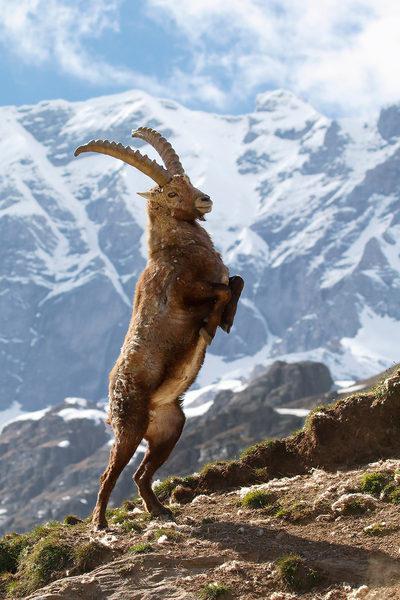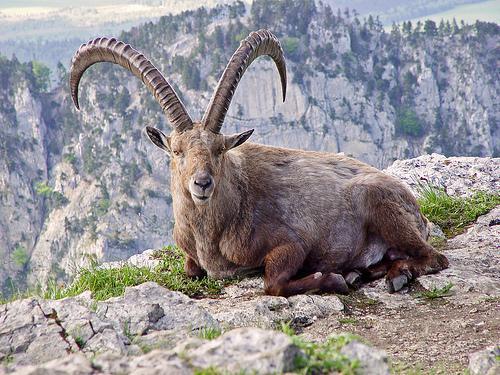The first image is the image on the left, the second image is the image on the right. Considering the images on both sides, is "One animal is standing on two feet in the image on the left." valid? Answer yes or no. Yes. The first image is the image on the left, the second image is the image on the right. For the images displayed, is the sentence "There's no more than one mountain goat in the right image." factually correct? Answer yes or no. Yes. 